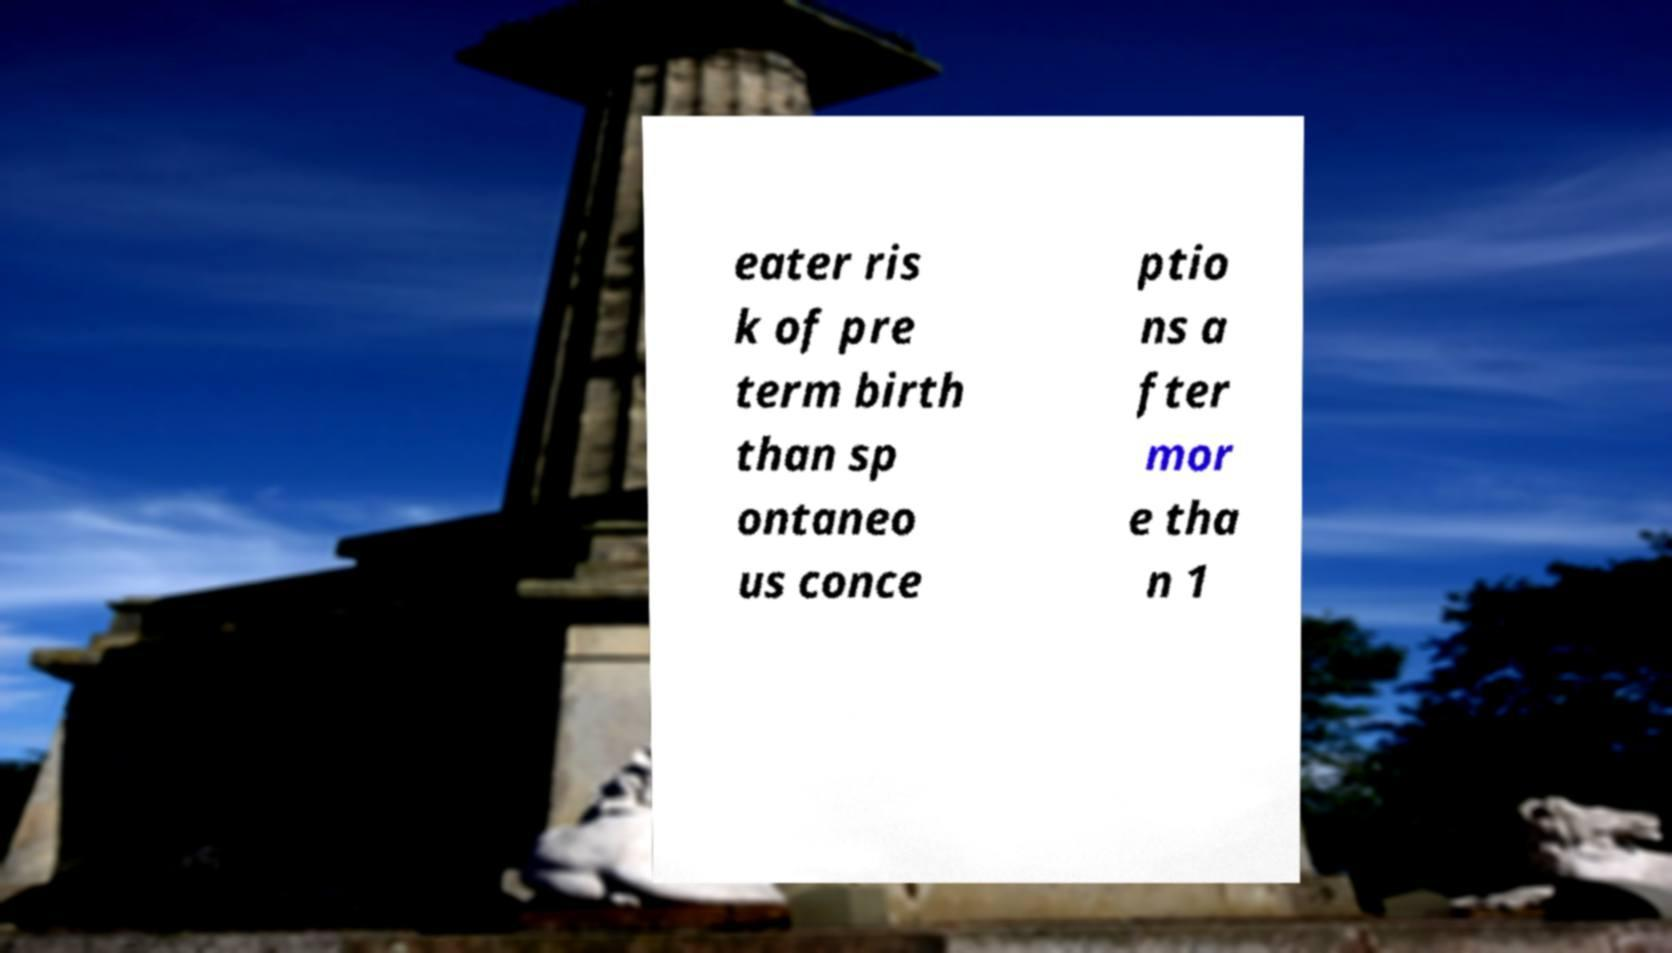There's text embedded in this image that I need extracted. Can you transcribe it verbatim? eater ris k of pre term birth than sp ontaneo us conce ptio ns a fter mor e tha n 1 